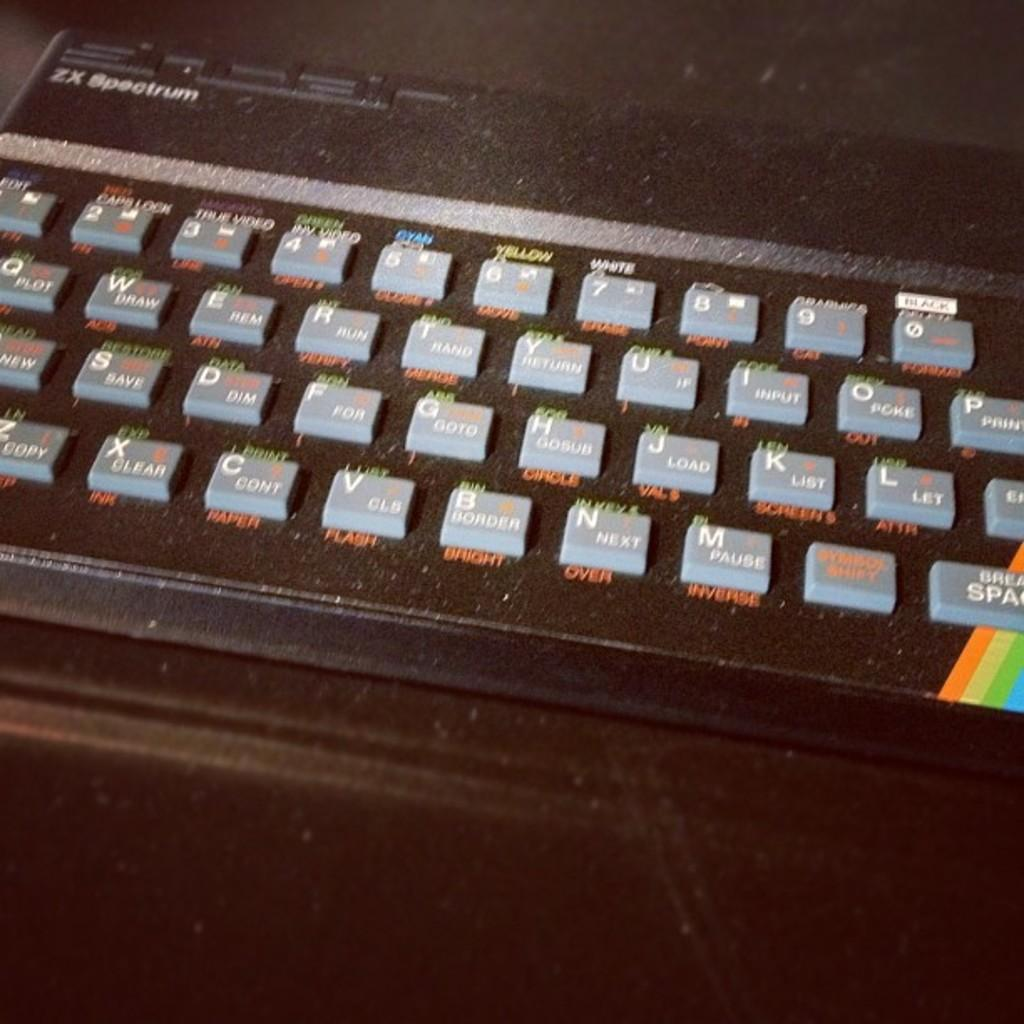Provide a one-sentence caption for the provided image. A black ZX Spectrum black keyboard with grey keys. 